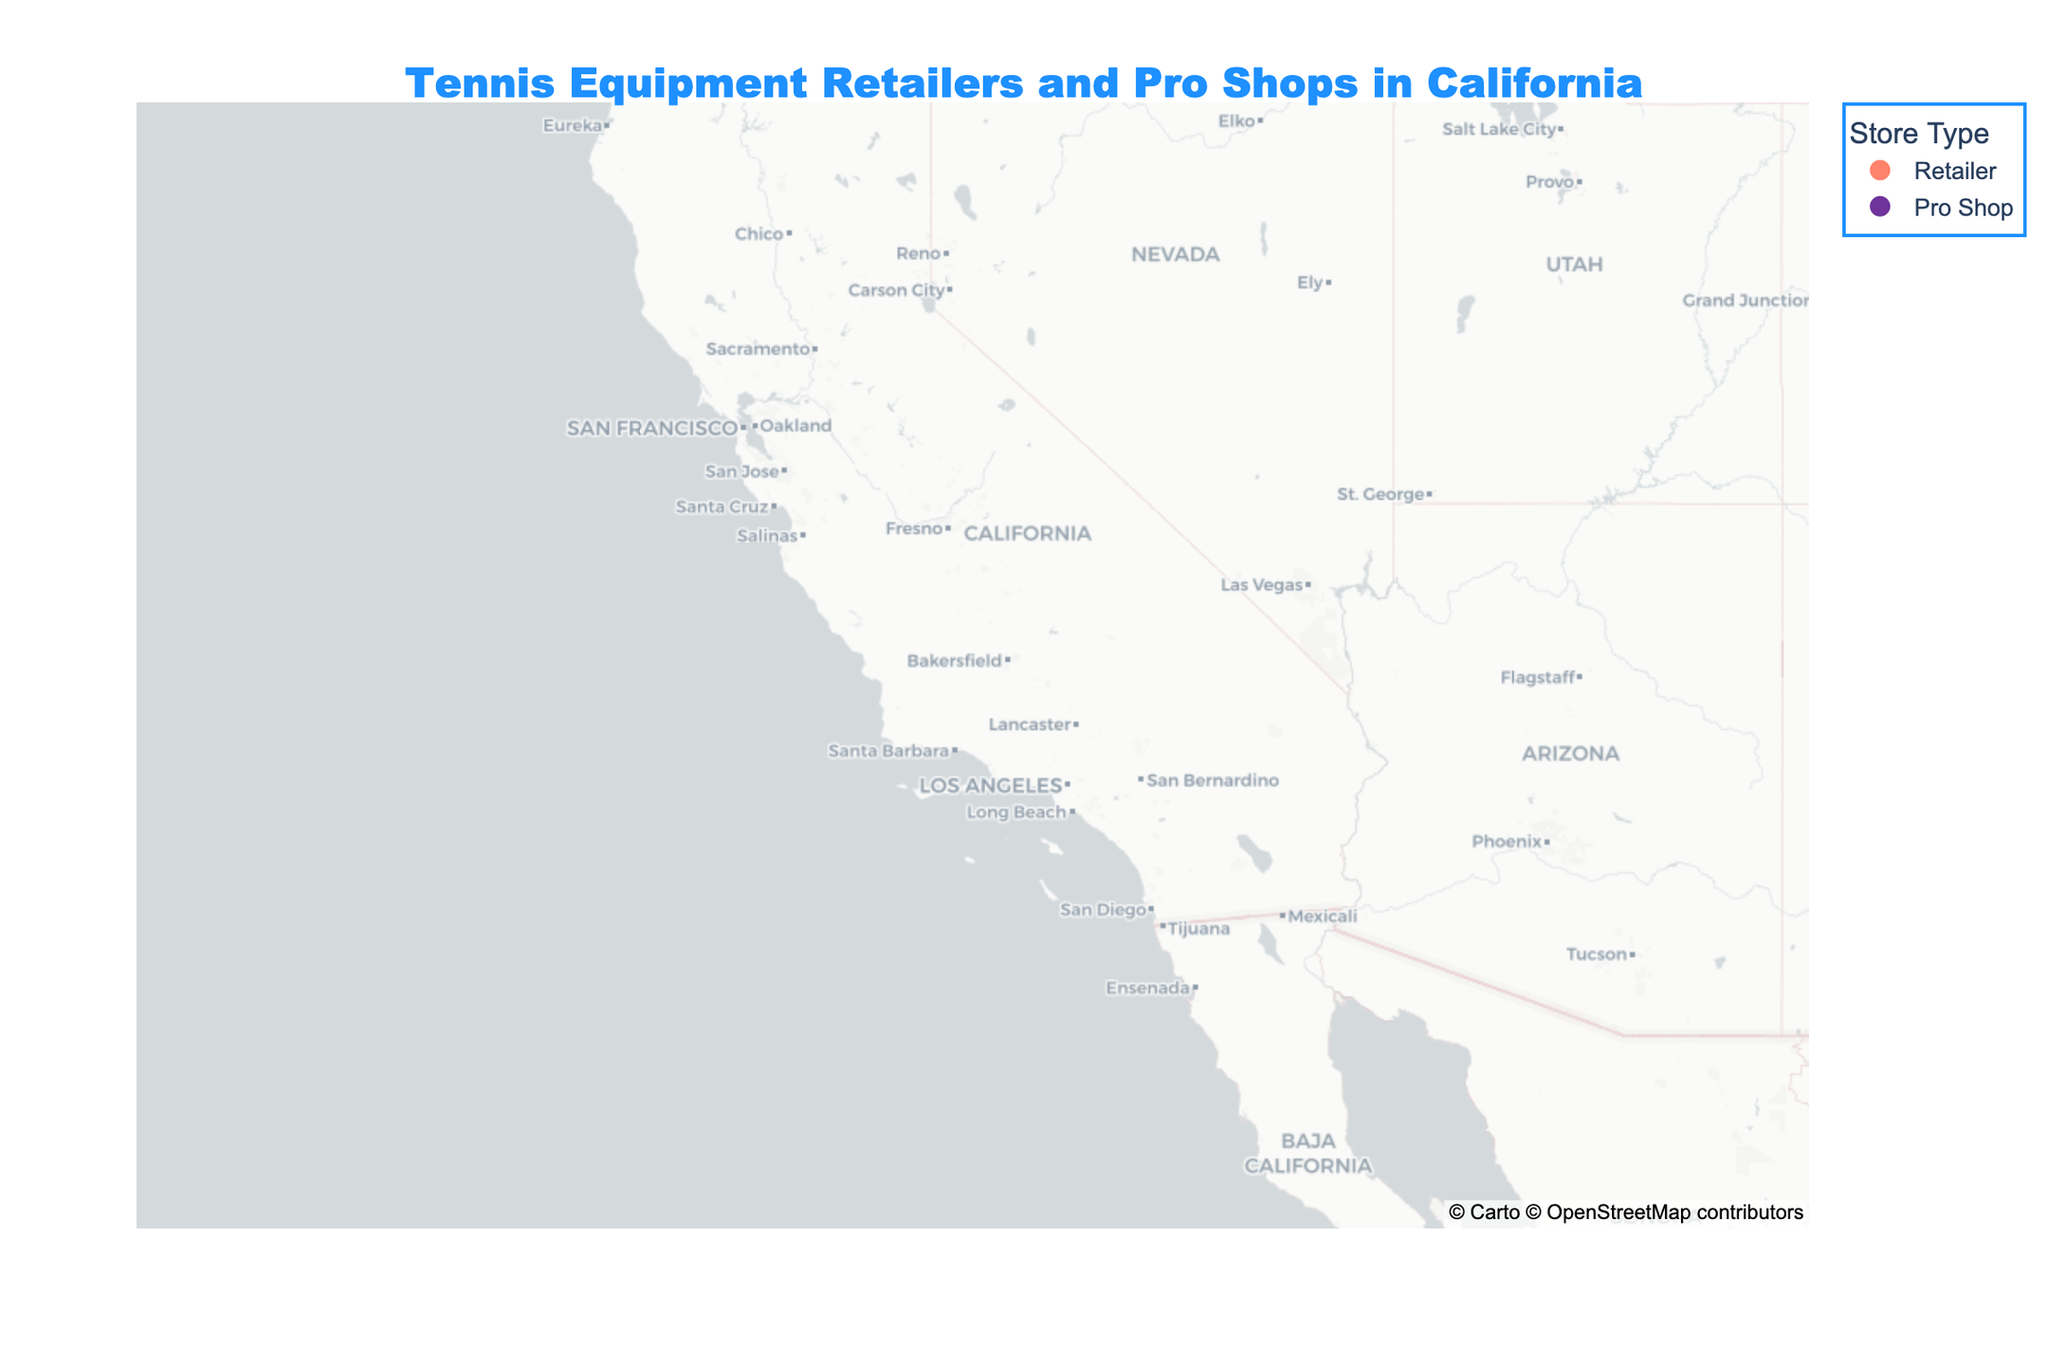What's the title of the figure? The title of the figure is usually prominently displayed at the top and provides a quick overview of the subject of the figure.
Answer: "Tennis Equipment Retailers and Pro Shops in California" What are the two different store types shown in the figure? The figure contains a legend that indicates different store types by color. By checking the color coding, you can identify the categories.
Answer: Retailer and Pro Shop Which store type is more prevalent in Los Angeles? Hovering over the data point in Los Angeles reveals the store name and type. By identifying this information, we can see which type it is.
Answer: Retailer In which city is Wine Country Tennis located? By hovering over the points and checking the hover information, we can locate Wine Country Tennis.
Answer: Napa How many pro shops are there in Southern California? To answer this, identify the cities in Southern California (e.g., Los Angeles, San Diego, Long Beach, Anaheim, Santa Monica, Newport Beach) and count how many data points corresponding to Pro Shops are present.
Answer: 5 Which store type is more densely located along the coast? Observing the distribution of colors along the coastal cities and comparing the number of data points can answer this question.
Answer: Pro Shops What's the average latitude of all the stores? To find this, sum the latitude values of all the stores and divide by the total number of stores. Average latitude = (Sum of all latitudes) / (Number of stores). Detailed steps involve: 34.0522 + 32.7157 + 37.7749 + 38.5816 + 36.7378 + 37.3382 + 33.7701 + 33.8366 + 34.4208 + 33.8303 + 36.6002 + 38.2975 + 34.0195 + 34.1478 + 33.6189 = 554.7426. Then divide by 15, 554.7426 / 15 = 36.9828.
Answer: 36.9828 Which city has multiple stores? Scan the hover information and check if any city appears in the data more than once.
Answer: None Are the Pro Shops more centrally located compared to Retailers? By examining the geographic distribution of Pro Shops vs. Retailers, one can compare their central concentration. Check whether Pro Shops are more concentrated around a central area compared to Retailers.
Answer: Yes Is there a city with both a Retailer and a Pro Shop? Identify all the cities and cross-check if both store types (by color coding) appear in the same city.
Answer: No 